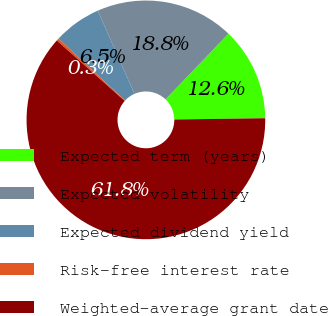Convert chart. <chart><loc_0><loc_0><loc_500><loc_500><pie_chart><fcel>Expected term (years)<fcel>Expected volatility<fcel>Expected dividend yield<fcel>Risk-free interest rate<fcel>Weighted-average grant date<nl><fcel>12.62%<fcel>18.77%<fcel>6.48%<fcel>0.33%<fcel>61.8%<nl></chart> 